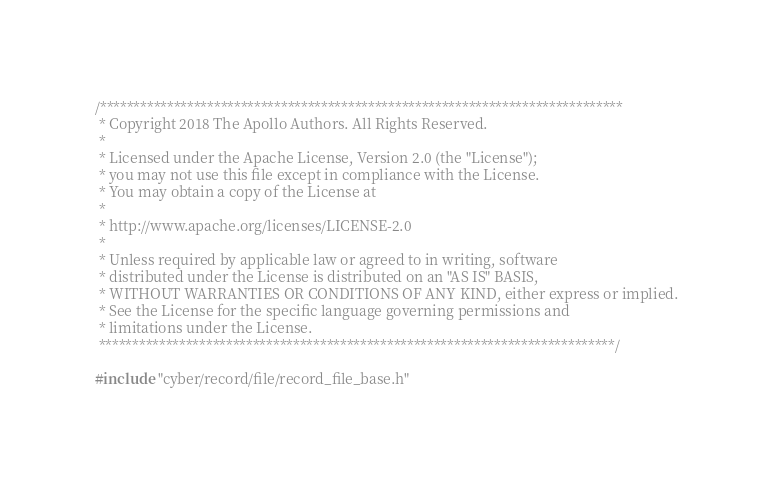Convert code to text. <code><loc_0><loc_0><loc_500><loc_500><_C++_>/******************************************************************************
 * Copyright 2018 The Apollo Authors. All Rights Reserved.
 *
 * Licensed under the Apache License, Version 2.0 (the "License");
 * you may not use this file except in compliance with the License.
 * You may obtain a copy of the License at
 *
 * http://www.apache.org/licenses/LICENSE-2.0
 *
 * Unless required by applicable law or agreed to in writing, software
 * distributed under the License is distributed on an "AS IS" BASIS,
 * WITHOUT WARRANTIES OR CONDITIONS OF ANY KIND, either express or implied.
 * See the License for the specific language governing permissions and
 * limitations under the License.
 *****************************************************************************/

#include "cyber/record/file/record_file_base.h"
</code> 